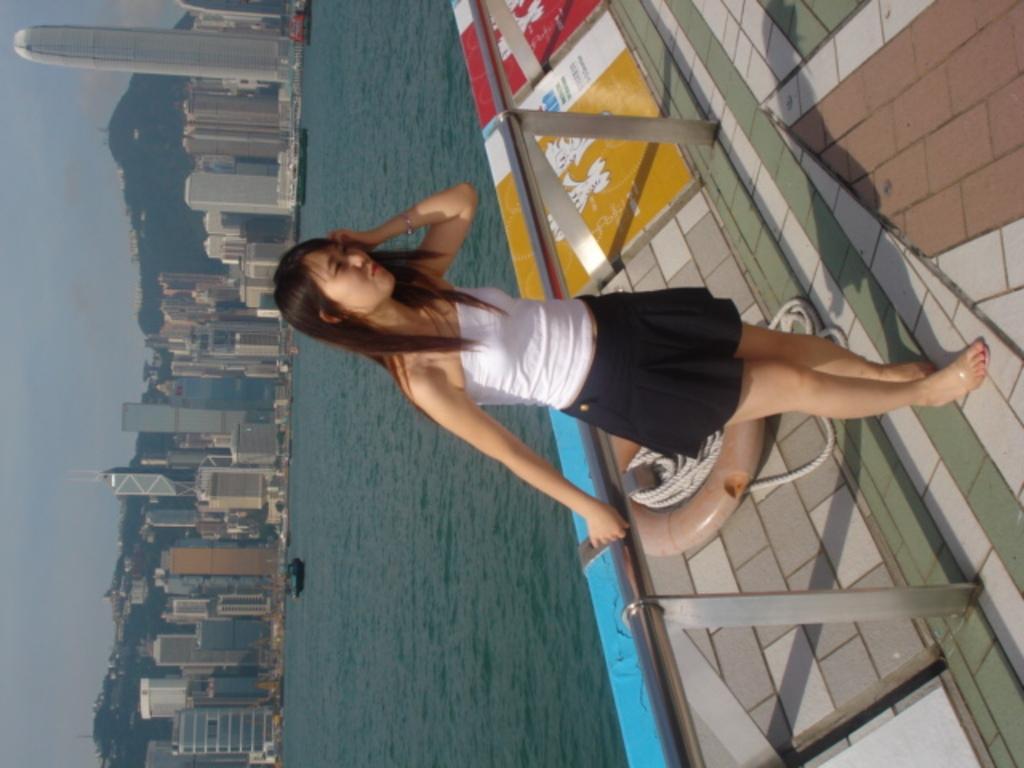Can you describe this image briefly? In the center of the image we can see a person is standing. Behind her, there is a railing, round shape object and rope. On the left side of the image, we can see the sky, buildings, water, hills, boats and a few other objects. 